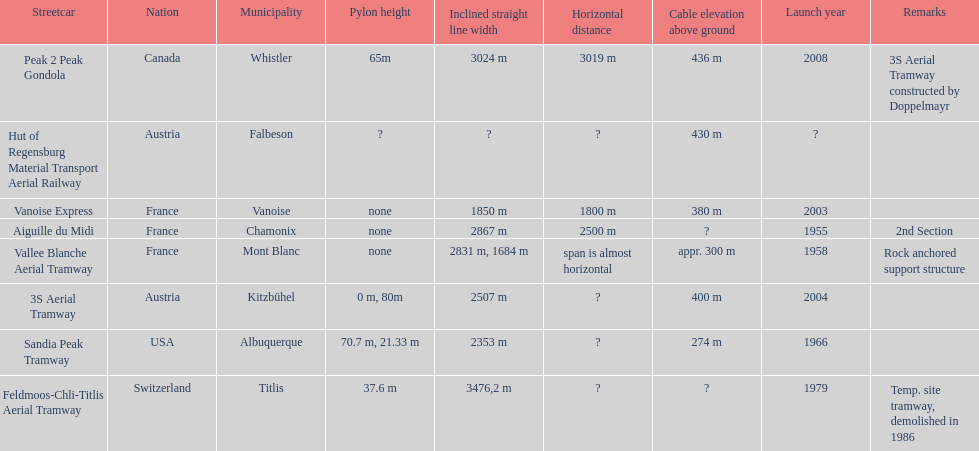Was the sandia peak tramway innagurate before or after the 3s aerial tramway? Before. 